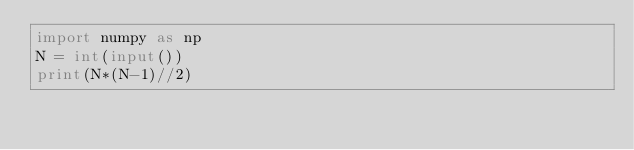Convert code to text. <code><loc_0><loc_0><loc_500><loc_500><_Python_>import numpy as np
N = int(input())
print(N*(N-1)//2)</code> 